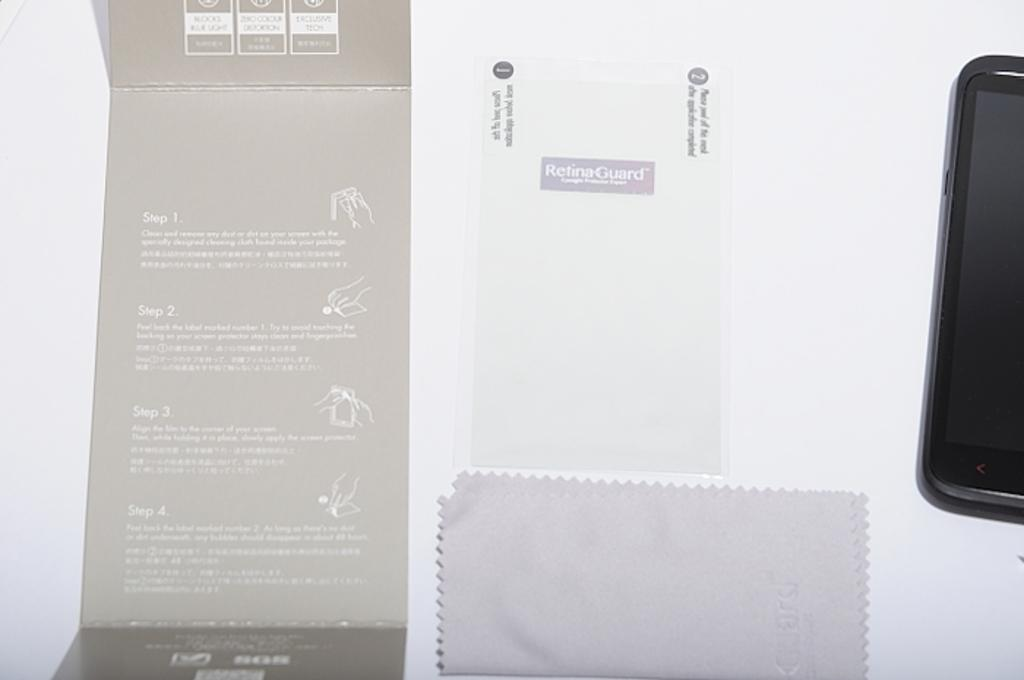<image>
Present a compact description of the photo's key features. A retina guard and a polishing cloth for a smart phone. 